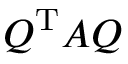<formula> <loc_0><loc_0><loc_500><loc_500>Q ^ { T } A Q</formula> 